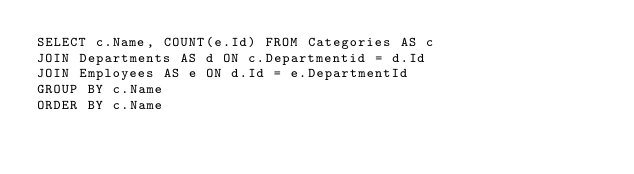Convert code to text. <code><loc_0><loc_0><loc_500><loc_500><_SQL_>SELECT c.Name, COUNT(e.Id) FROM Categories AS c
JOIN Departments AS d ON c.Departmentid = d.Id
JOIN Employees AS e ON d.Id = e.DepartmentId
GROUP BY c.Name
ORDER BY c.Name</code> 